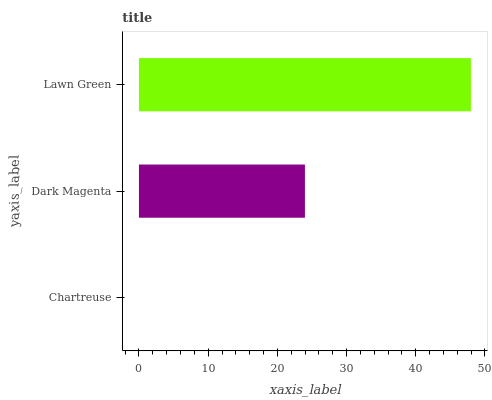Is Chartreuse the minimum?
Answer yes or no. Yes. Is Lawn Green the maximum?
Answer yes or no. Yes. Is Dark Magenta the minimum?
Answer yes or no. No. Is Dark Magenta the maximum?
Answer yes or no. No. Is Dark Magenta greater than Chartreuse?
Answer yes or no. Yes. Is Chartreuse less than Dark Magenta?
Answer yes or no. Yes. Is Chartreuse greater than Dark Magenta?
Answer yes or no. No. Is Dark Magenta less than Chartreuse?
Answer yes or no. No. Is Dark Magenta the high median?
Answer yes or no. Yes. Is Dark Magenta the low median?
Answer yes or no. Yes. Is Lawn Green the high median?
Answer yes or no. No. Is Lawn Green the low median?
Answer yes or no. No. 